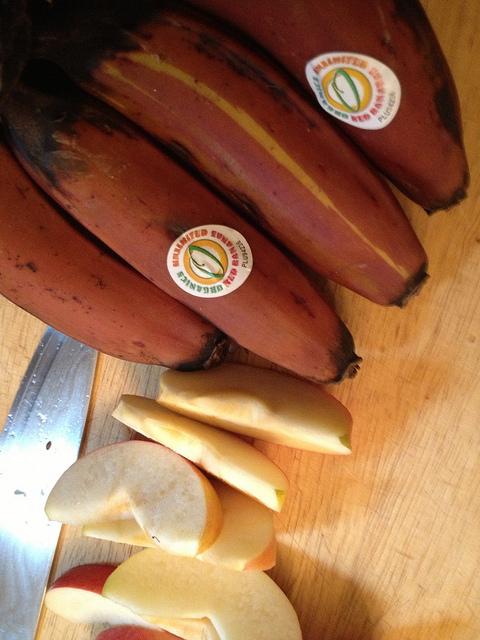Are the bananas ripe?
Answer briefly. Yes. What brand bananas are they?
Short answer required. Organic. What fruit is already sliced?
Answer briefly. Apple. 